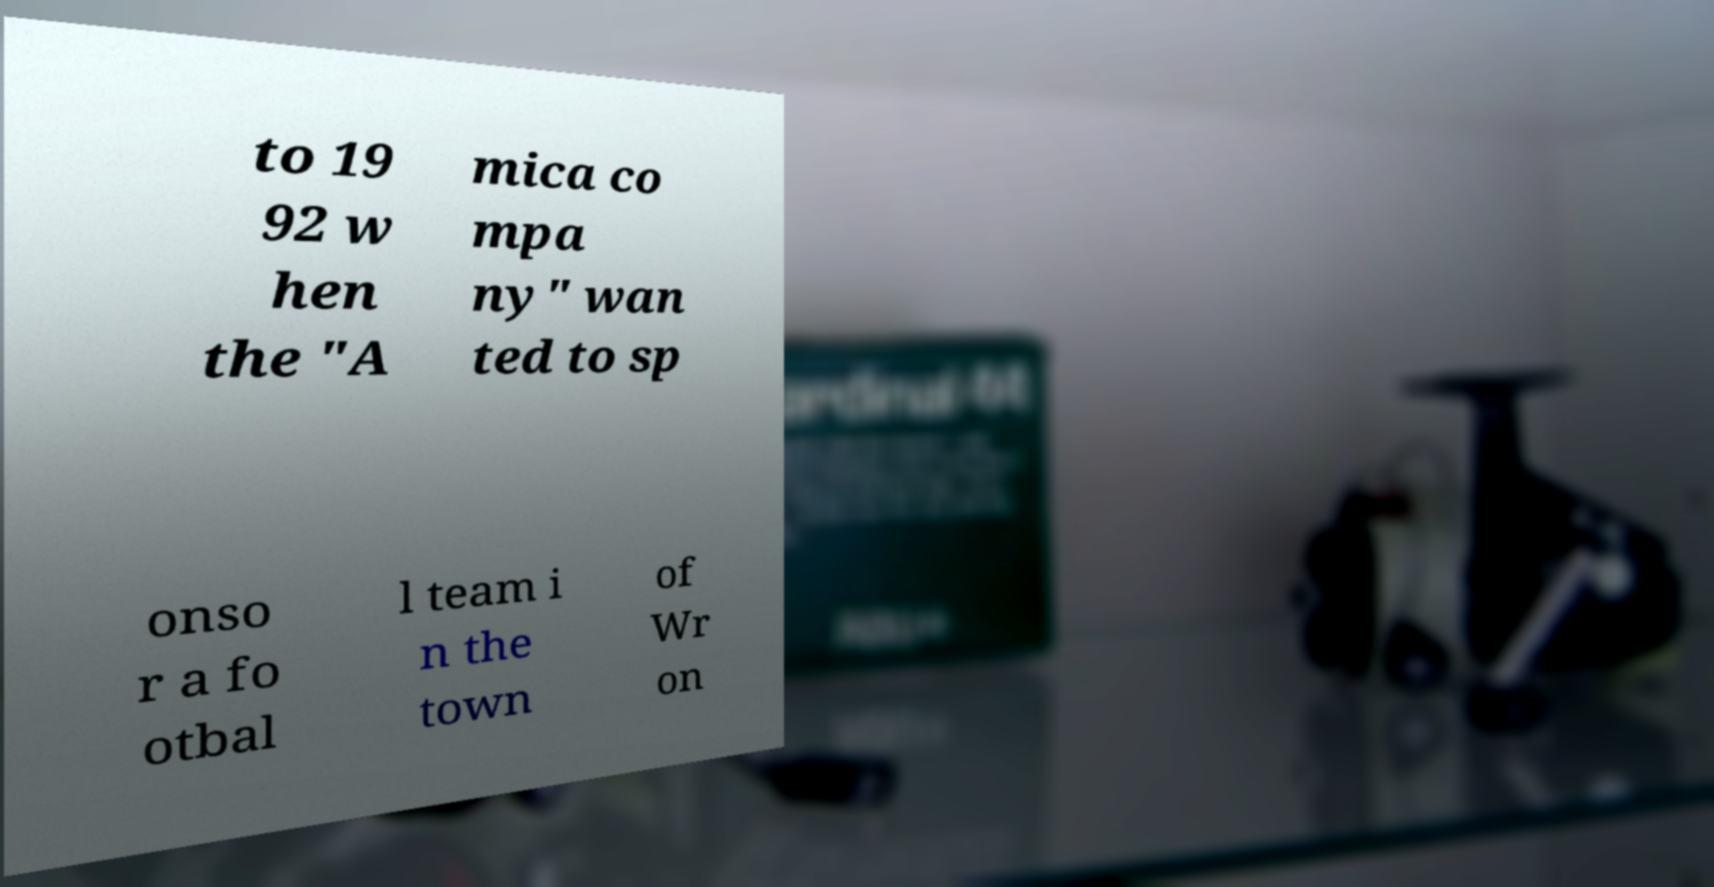There's text embedded in this image that I need extracted. Can you transcribe it verbatim? to 19 92 w hen the "A mica co mpa ny" wan ted to sp onso r a fo otbal l team i n the town of Wr on 